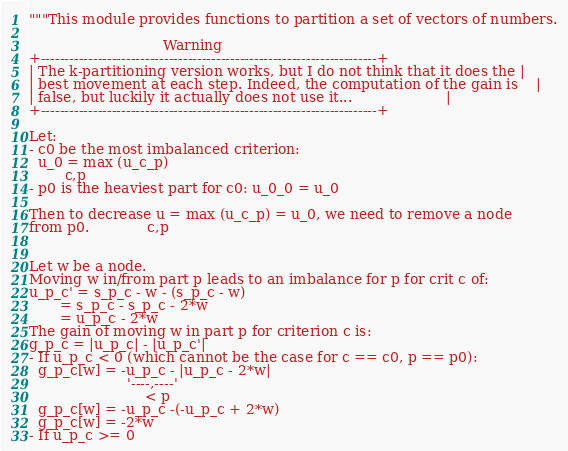<code> <loc_0><loc_0><loc_500><loc_500><_Python_>"""This module provides functions to partition a set of vectors of numbers.

                              Warning
+-----------------------------------------------------------------------+
| The k-partitioning version works, but I do not think that it does the |
| best movement at each step. Indeed, the computation of the gain is    |
| false, but luckily it actually does not use it...                     |
+-----------------------------------------------------------------------+

Let:
- c0 be the most imbalanced criterion:
  u_0 = max (u_c_p)
        c,p
- p0 is the heaviest part for c0: u_0_0 = u_0

Then to decrease u = max (u_c_p) = u_0, we need to remove a node
from p0.             c,p


Let w be a node.
Moving w in/from part p leads to an imbalance for p for crit c of:
u_p_c' = s_p_c - w - (s_p_c - w)
       = s_p_c - s_p_c - 2*w
       = u_p_c - 2*w
The gain of moving w in part p for criterion c is:
g_p_c = |u_p_c| - |u_p_c'|
- If u_p_c < 0 (which cannot be the case for c == c0, p == p0):
  g_p_c[w] = -u_p_c - |u_p_c - 2*w|
                      '----,----'
                          < p
  g_p_c[w] = -u_p_c -(-u_p_c + 2*w)
  g_p_c[w] = -2*w
- If u_p_c >= 0</code> 